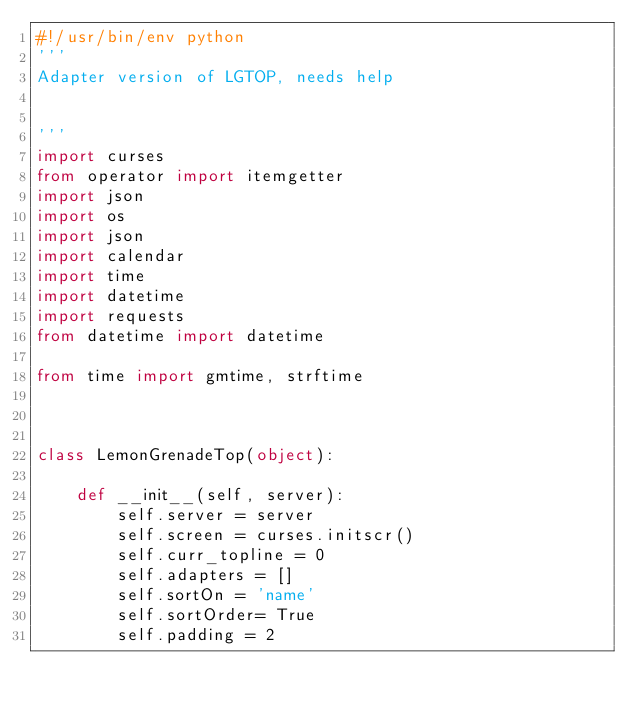Convert code to text. <code><loc_0><loc_0><loc_500><loc_500><_Python_>#!/usr/bin/env python
'''
Adapter version of LGTOP, needs help


'''
import curses
from operator import itemgetter
import json
import os
import json
import calendar
import time
import datetime
import requests
from datetime import datetime

from time import gmtime, strftime



class LemonGrenadeTop(object):

    def __init__(self, server):
        self.server = server
        self.screen = curses.initscr()
        self.curr_topline = 0
        self.adapters = []
        self.sortOn = 'name'
        self.sortOrder= True
        self.padding = 2</code> 